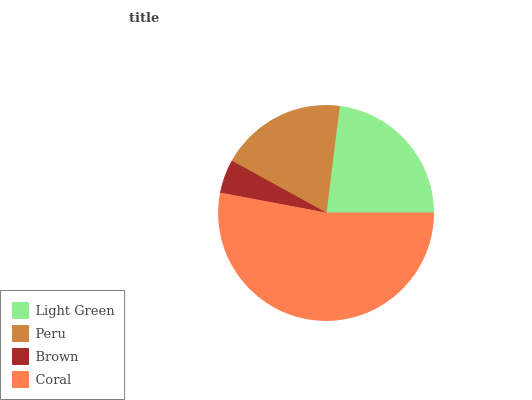Is Brown the minimum?
Answer yes or no. Yes. Is Coral the maximum?
Answer yes or no. Yes. Is Peru the minimum?
Answer yes or no. No. Is Peru the maximum?
Answer yes or no. No. Is Light Green greater than Peru?
Answer yes or no. Yes. Is Peru less than Light Green?
Answer yes or no. Yes. Is Peru greater than Light Green?
Answer yes or no. No. Is Light Green less than Peru?
Answer yes or no. No. Is Light Green the high median?
Answer yes or no. Yes. Is Peru the low median?
Answer yes or no. Yes. Is Peru the high median?
Answer yes or no. No. Is Brown the low median?
Answer yes or no. No. 